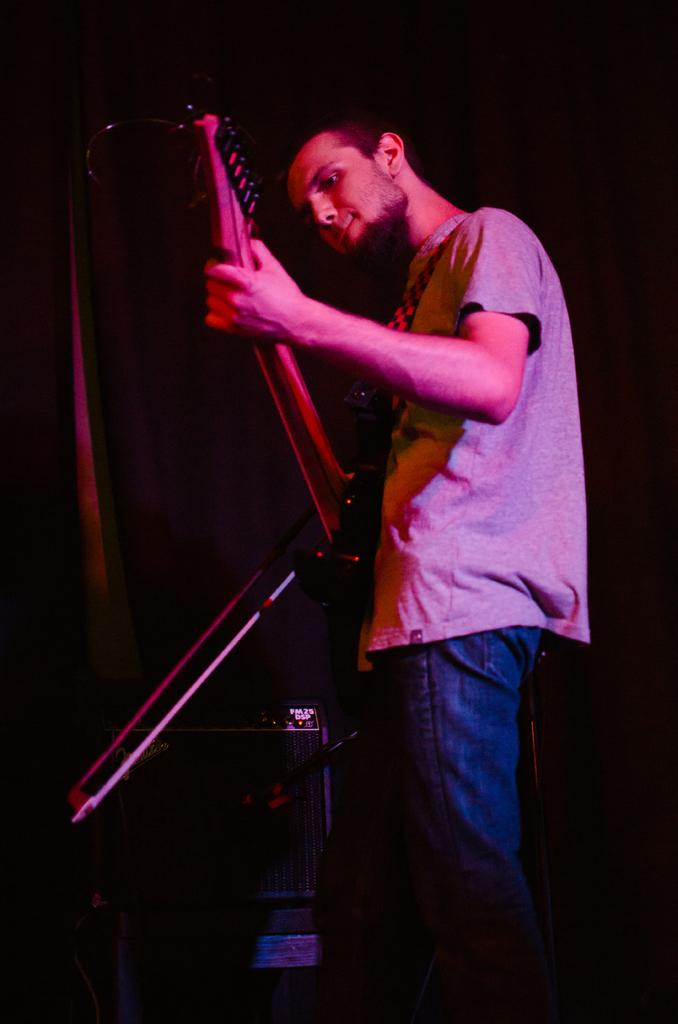What is the main subject of the image? There is a man in the image. What is the man doing in the image? The man is playing a guitar. How many fish are visible on the stage in the image? There is no stage or fish present in the image; it features a man playing a guitar. What type of linen is draped over the guitar in the image? There is no linen present in the image; the guitar is not covered. 